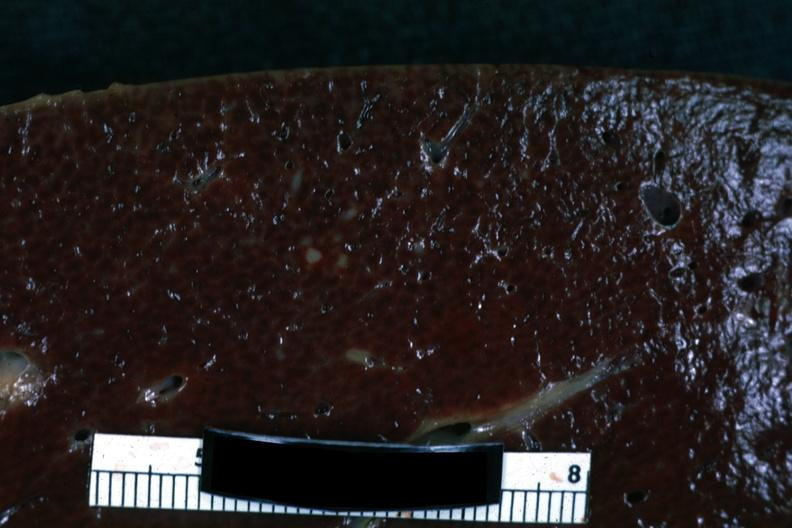what is present?
Answer the question using a single word or phrase. Hodgkins disease 